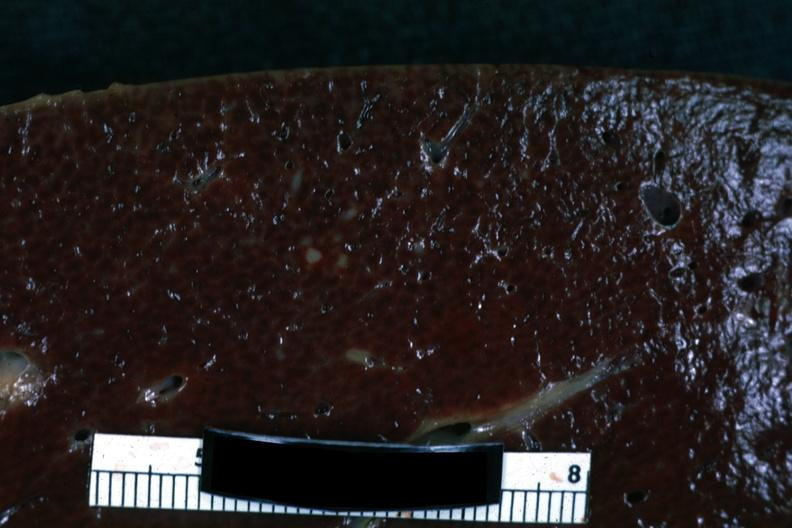what is present?
Answer the question using a single word or phrase. Hodgkins disease 